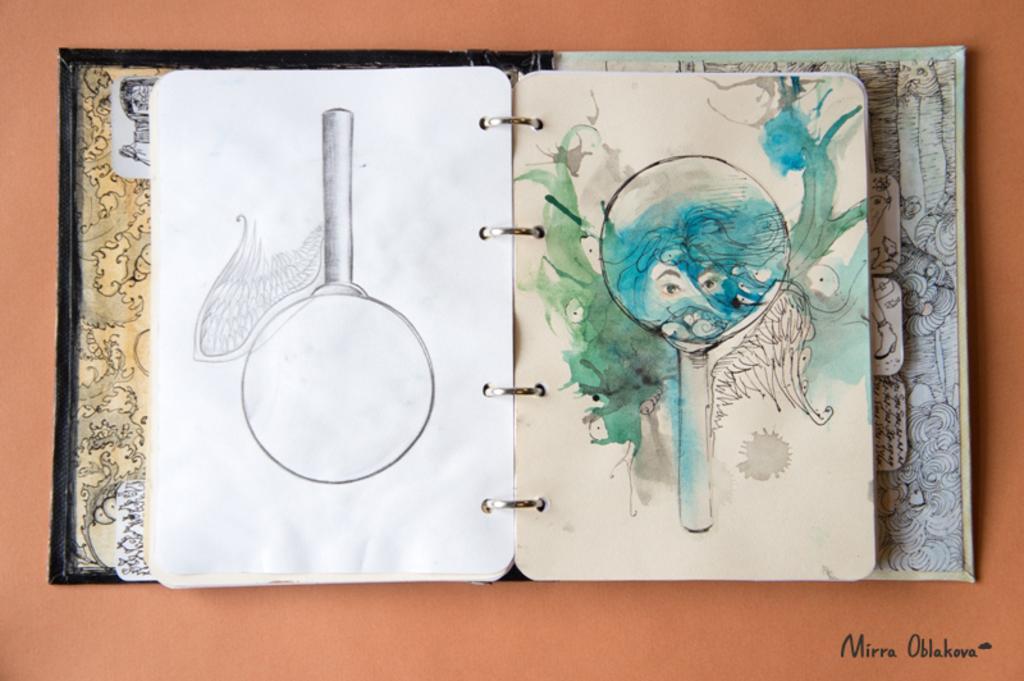How would you summarize this image in a sentence or two? In this image we can see a book. In the book there are the pictures of cartoons. 